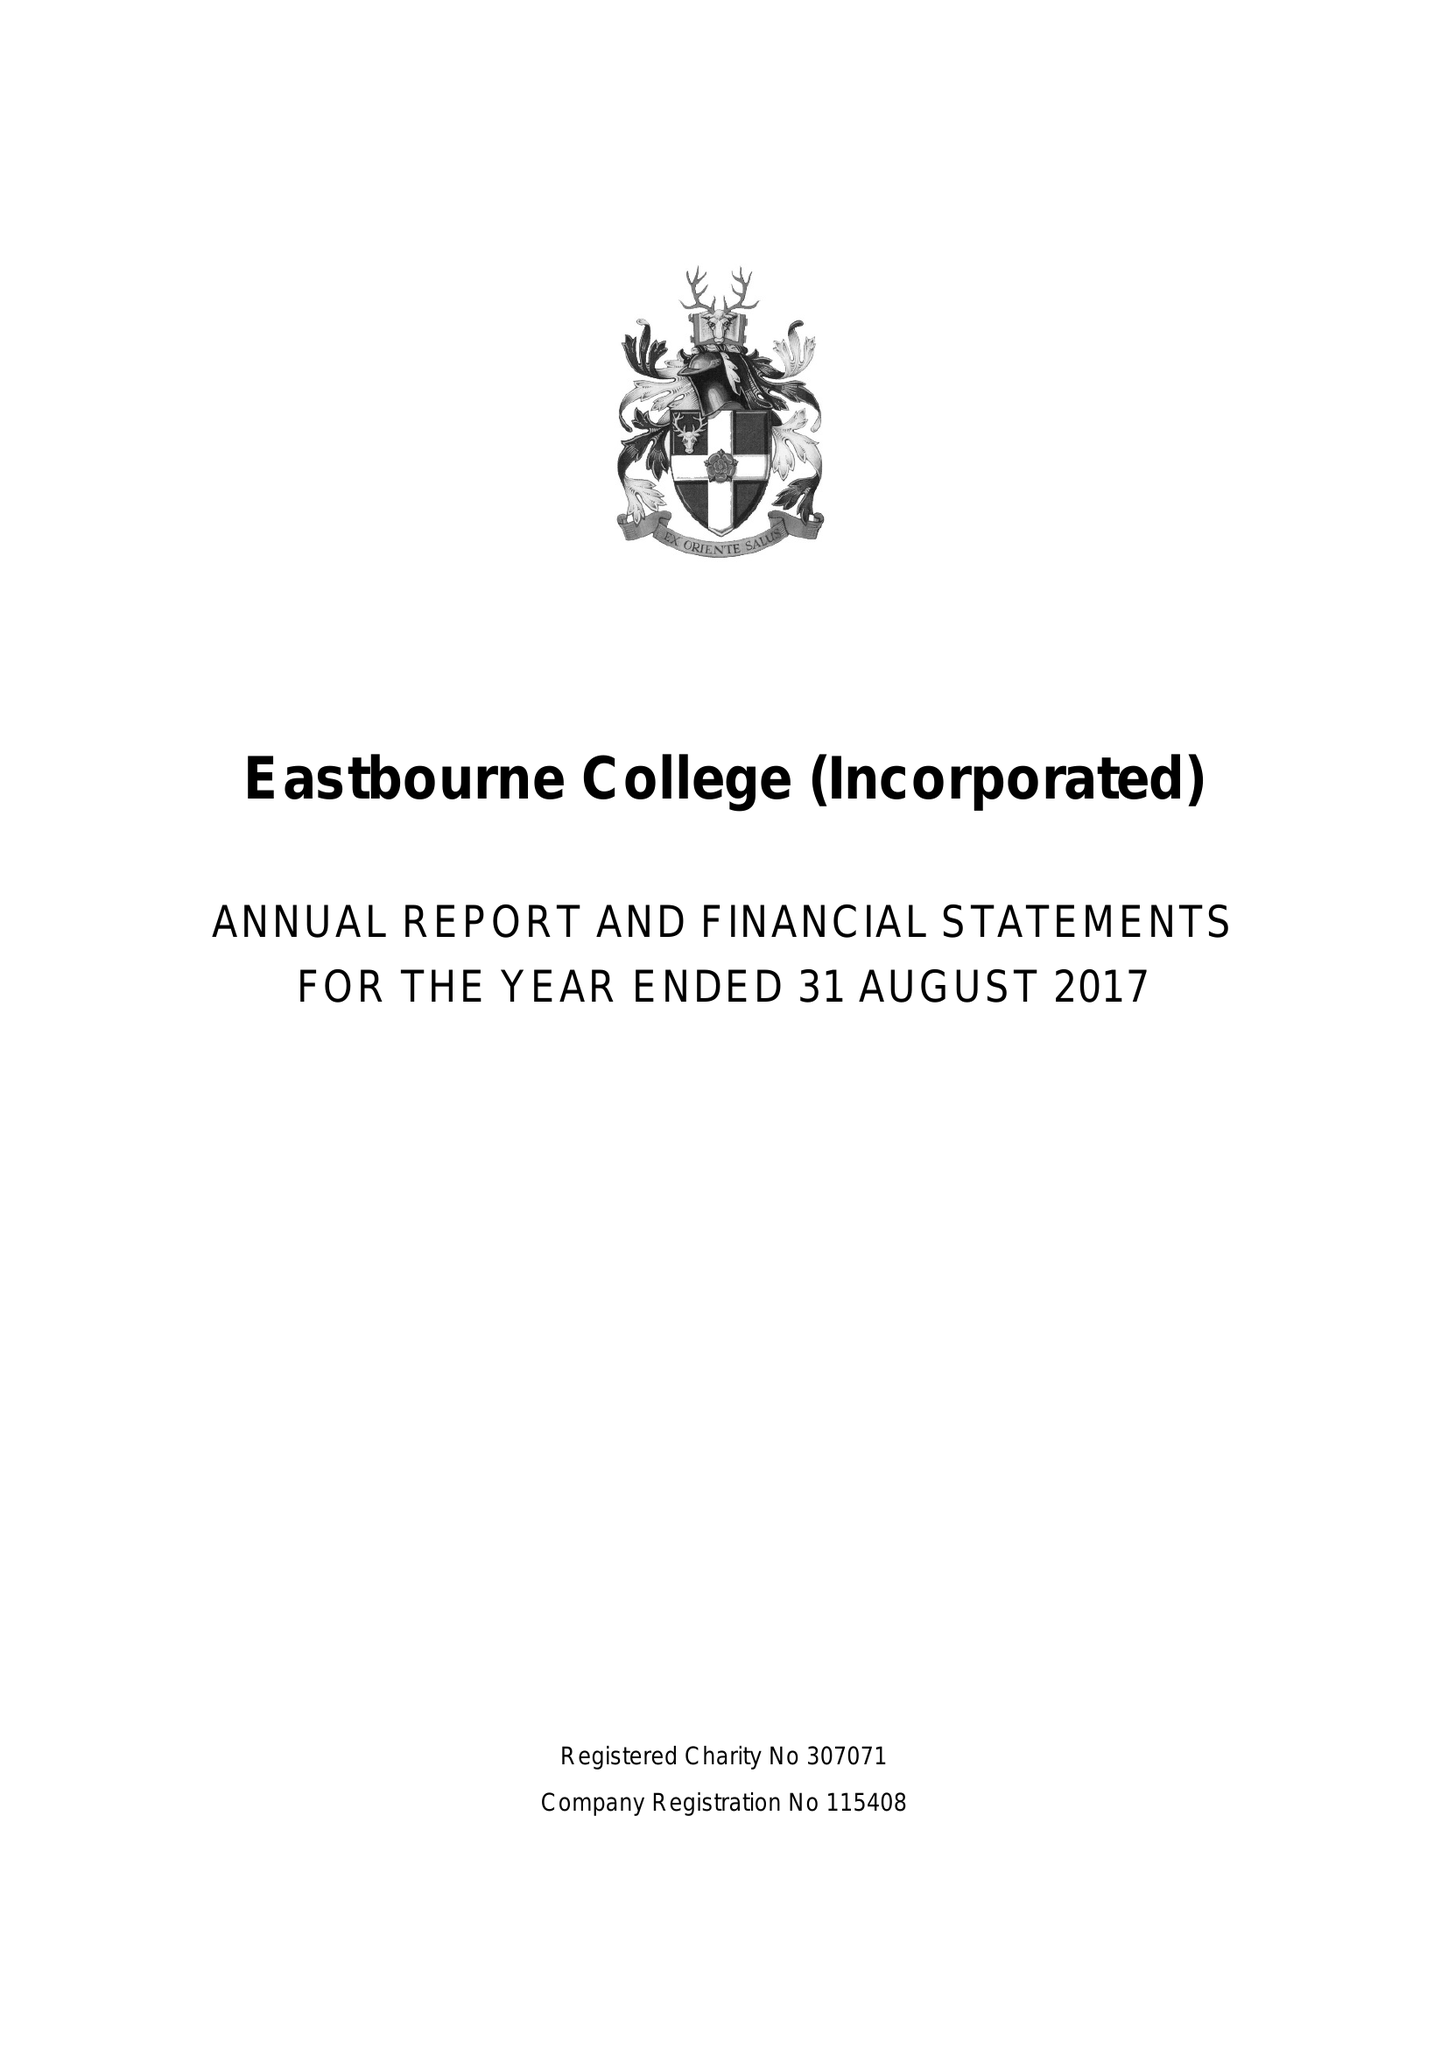What is the value for the income_annually_in_british_pounds?
Answer the question using a single word or phrase. 21650000.00 